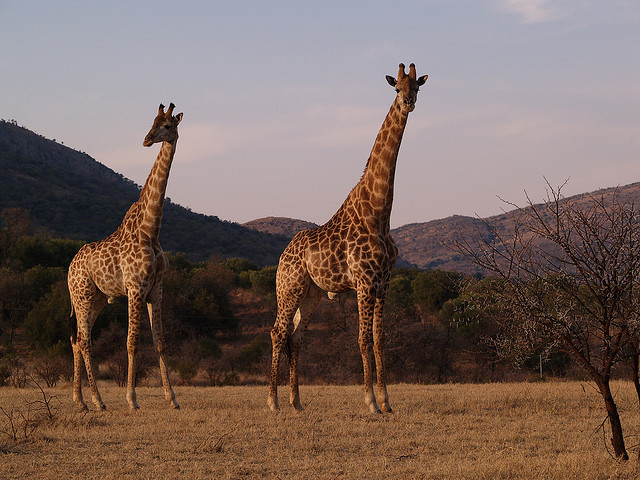<image>What is the one giraffe looking at off to the side? I don't know exactly what the giraffe is looking at. It might be trees, grass, other giraffes, or even a zebra. What is the one giraffe looking at off to the side? I don't know what the giraffe is looking at off to the side. It can be trees, camera, grass, other giraffes, or a zebra. 